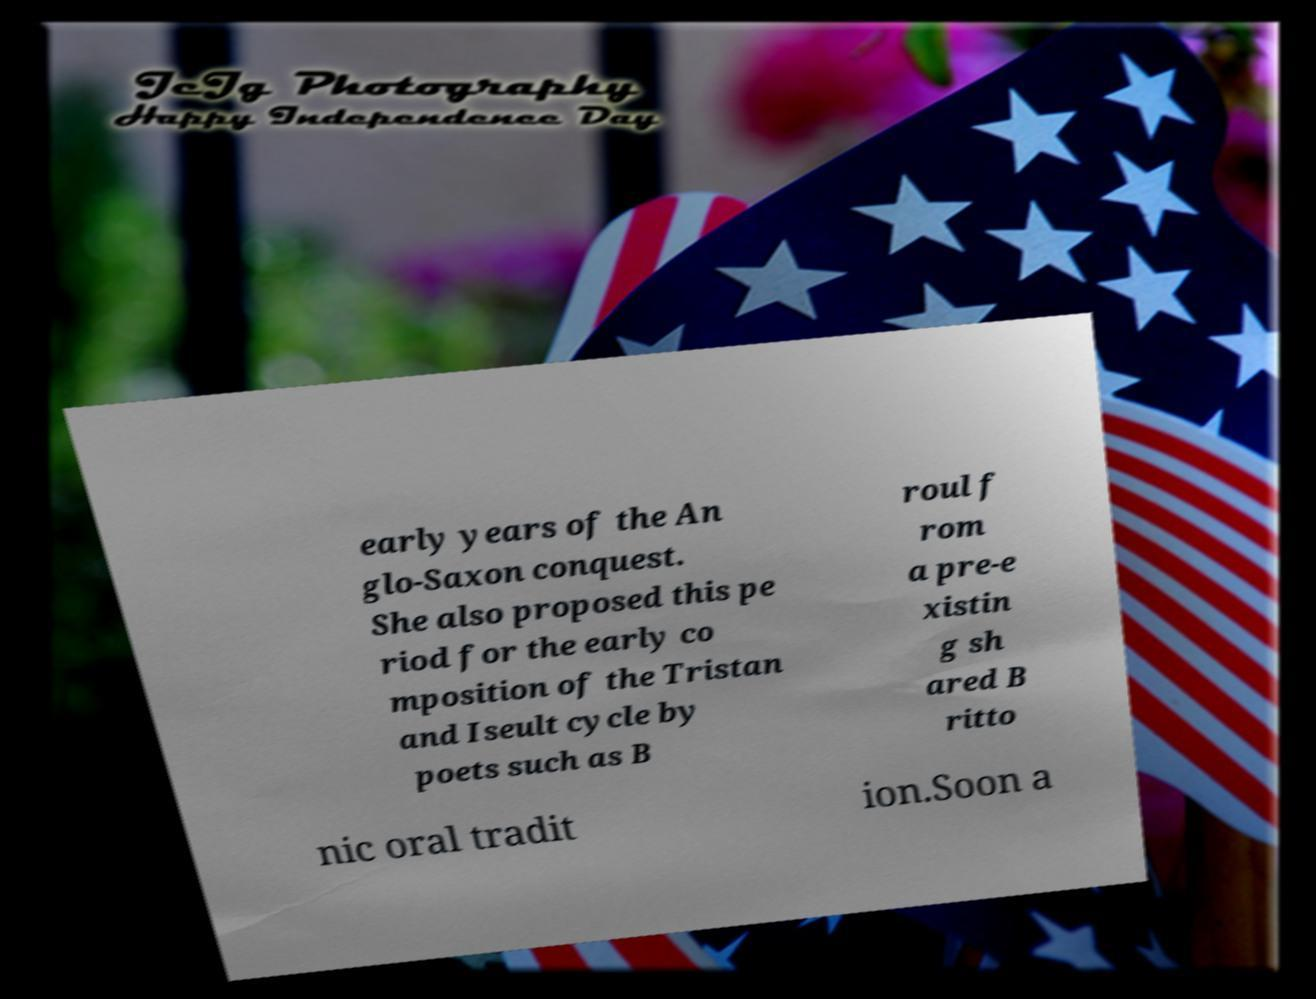Can you accurately transcribe the text from the provided image for me? early years of the An glo-Saxon conquest. She also proposed this pe riod for the early co mposition of the Tristan and Iseult cycle by poets such as B roul f rom a pre-e xistin g sh ared B ritto nic oral tradit ion.Soon a 